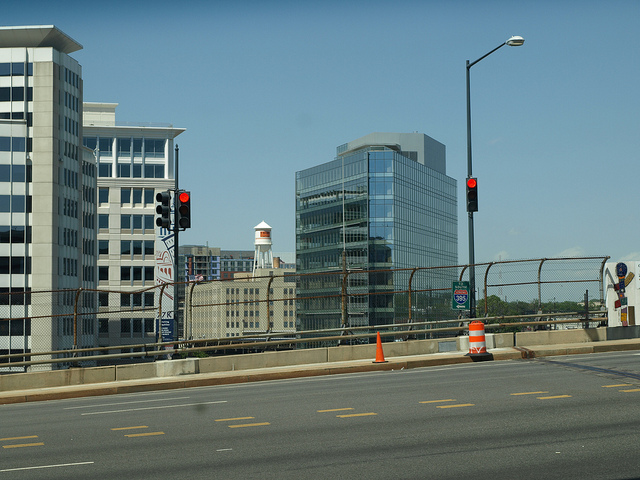<image>When were these stoplights installed in the picture? It is unknown when the stoplights were installed in the picture. When were these stoplights installed in the picture? I don't know when these stoplights were installed in the picture. It could have been recently or a while ago. 